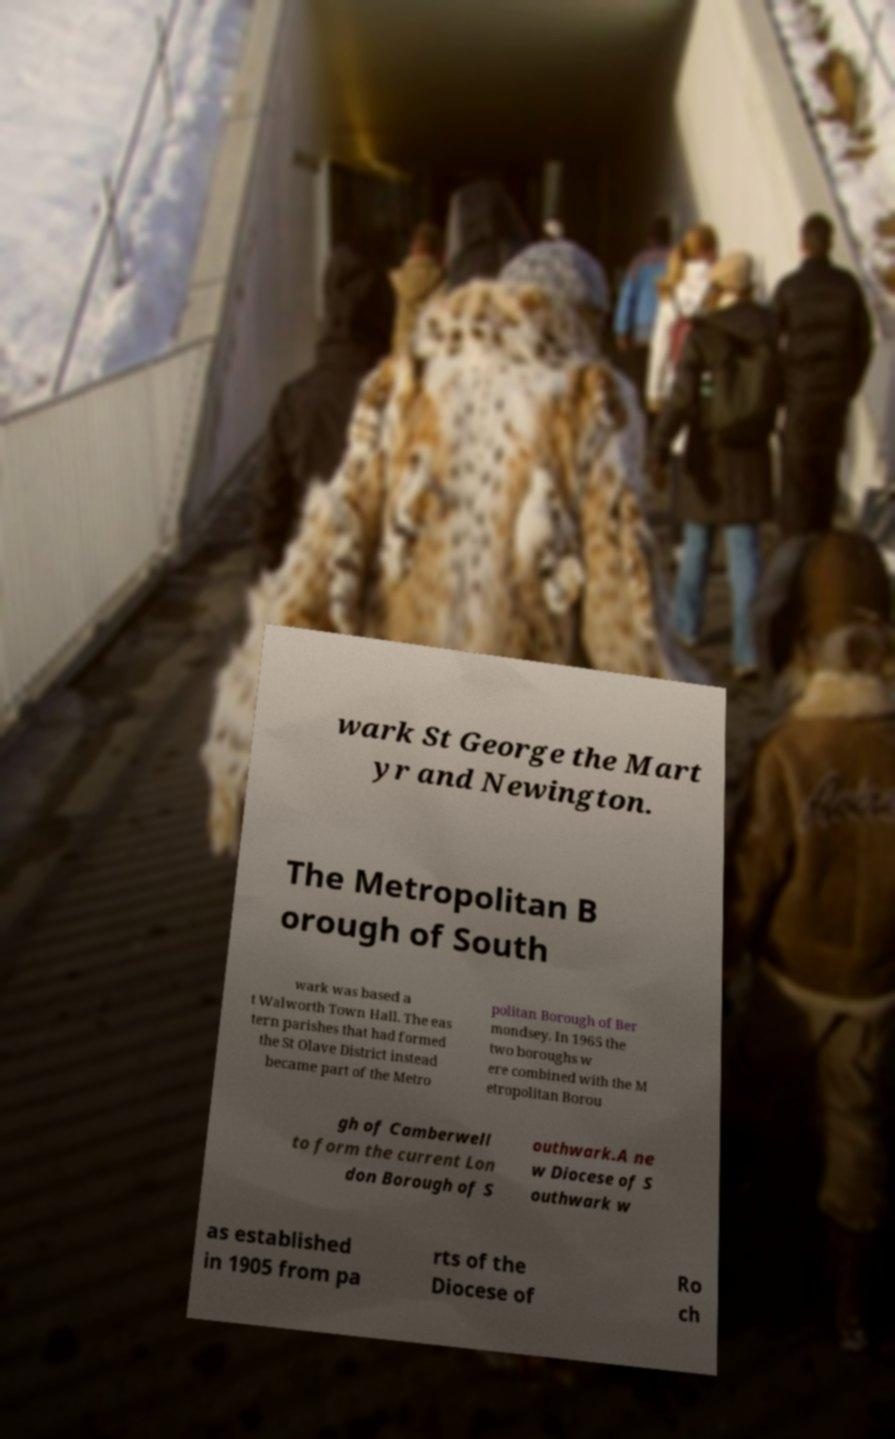There's text embedded in this image that I need extracted. Can you transcribe it verbatim? wark St George the Mart yr and Newington. The Metropolitan B orough of South wark was based a t Walworth Town Hall. The eas tern parishes that had formed the St Olave District instead became part of the Metro politan Borough of Ber mondsey. In 1965 the two boroughs w ere combined with the M etropolitan Borou gh of Camberwell to form the current Lon don Borough of S outhwark.A ne w Diocese of S outhwark w as established in 1905 from pa rts of the Diocese of Ro ch 